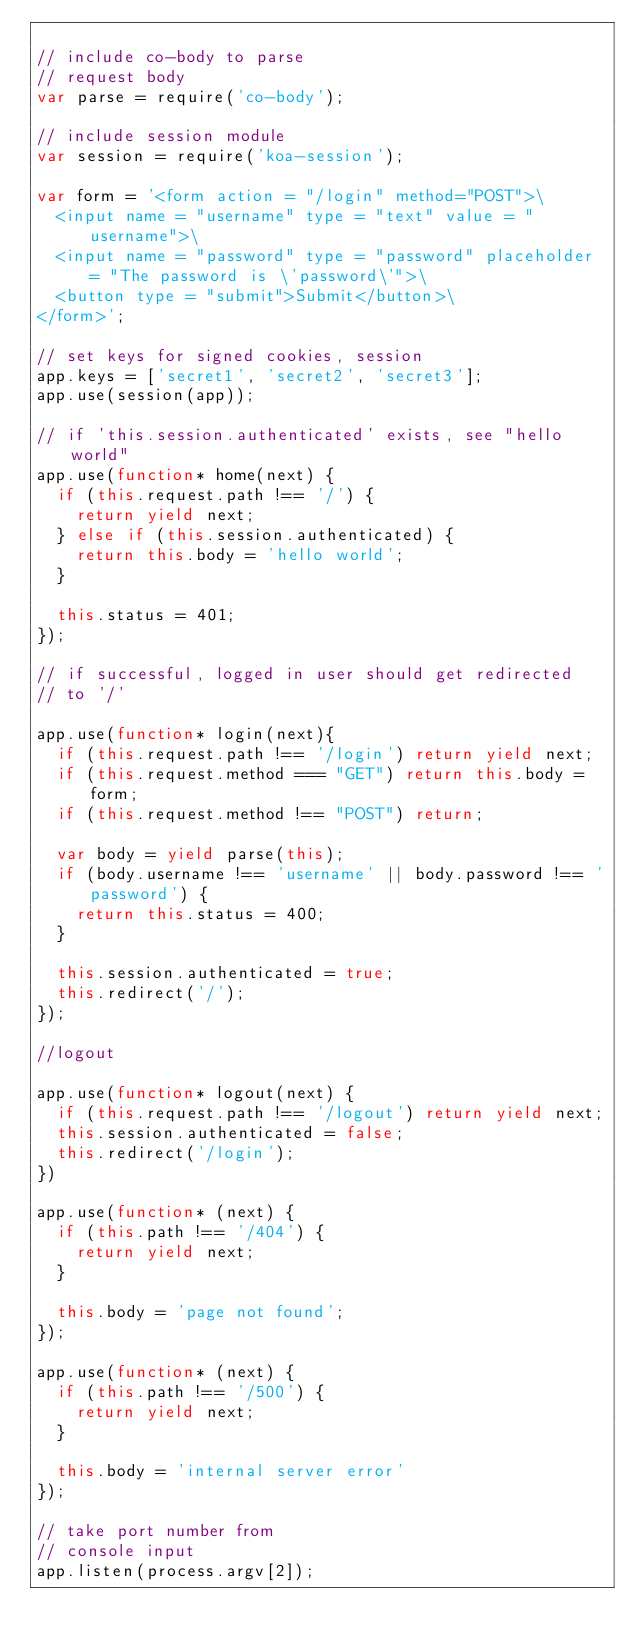Convert code to text. <code><loc_0><loc_0><loc_500><loc_500><_JavaScript_>
// include co-body to parse
// request body
var parse = require('co-body');

// include session module
var session = require('koa-session');

var form = '<form action = "/login" method="POST">\
  <input name = "username" type = "text" value = "username">\
  <input name = "password" type = "password" placeholder = "The password is \'password\'">\
  <button type = "submit">Submit</button>\
</form>';

// set keys for signed cookies, session
app.keys = ['secret1', 'secret2', 'secret3'];
app.use(session(app));

// if 'this.session.authenticated' exists, see "hello world"
app.use(function* home(next) {
  if (this.request.path !== '/') {
    return yield next;
  } else if (this.session.authenticated) {
    return this.body = 'hello world';
  }

  this.status = 401;
});

// if successful, logged in user should get redirected
// to '/'

app.use(function* login(next){
  if (this.request.path !== '/login') return yield next;
  if (this.request.method === "GET") return this.body = form;
  if (this.request.method !== "POST") return;

  var body = yield parse(this);
  if (body.username !== 'username' || body.password !== 'password') {
    return this.status = 400;
  }

  this.session.authenticated = true;
  this.redirect('/');
});

//logout

app.use(function* logout(next) {
  if (this.request.path !== '/logout') return yield next;
  this.session.authenticated = false;
  this.redirect('/login');
})

app.use(function* (next) {
  if (this.path !== '/404') {
    return yield next;
  }

  this.body = 'page not found';
});

app.use(function* (next) {
  if (this.path !== '/500') {
    return yield next;
  }

  this.body = 'internal server error'
});

// take port number from
// console input
app.listen(process.argv[2]);
</code> 